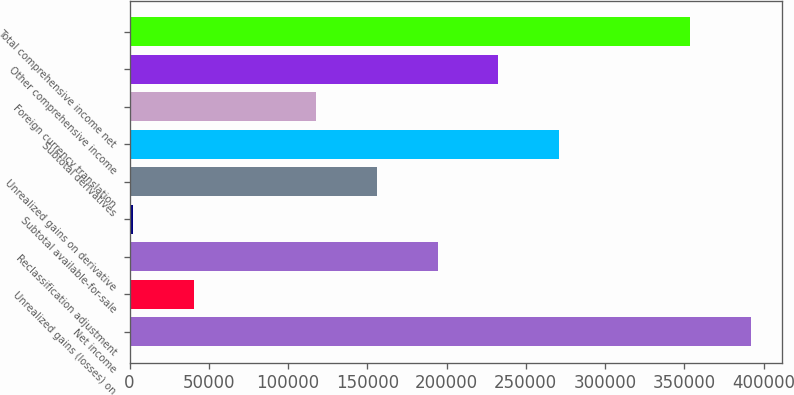Convert chart. <chart><loc_0><loc_0><loc_500><loc_500><bar_chart><fcel>Net income<fcel>Unrealized gains (losses) on<fcel>Reclassification adjustment<fcel>Subtotal available-for-sale<fcel>Unrealized gains on derivative<fcel>Subtotal derivatives<fcel>Foreign currency translation<fcel>Other comprehensive income<fcel>Total comprehensive income net<nl><fcel>392174<fcel>40532.7<fcel>194300<fcel>2091<fcel>155858<fcel>271183<fcel>117416<fcel>232741<fcel>353732<nl></chart> 